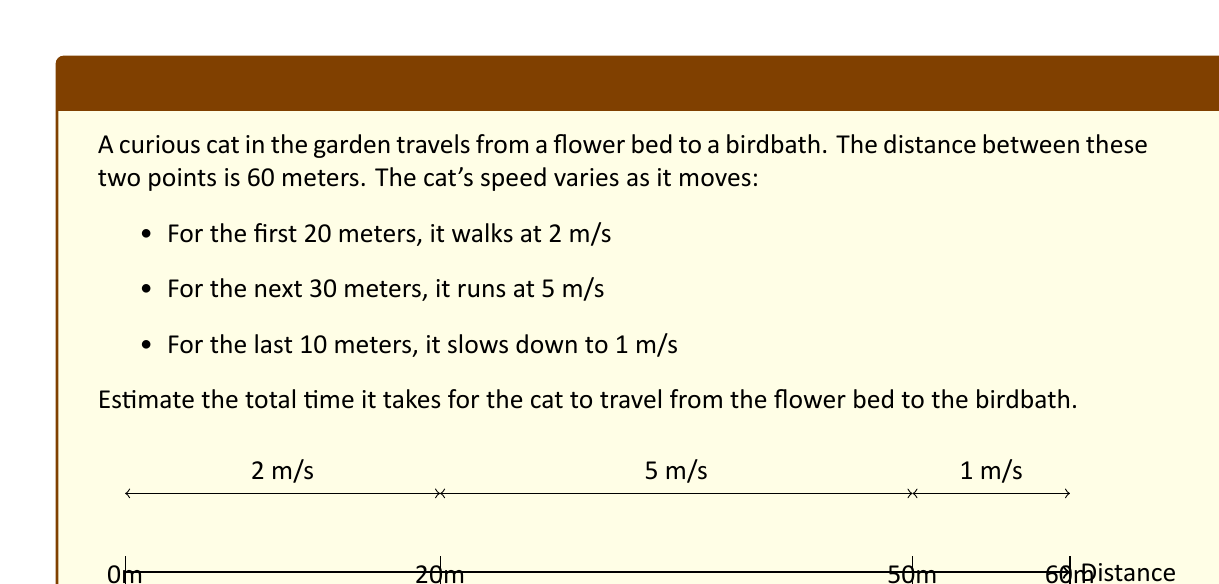Give your solution to this math problem. Let's break this problem down into steps:

1) We need to calculate the time for each segment of the journey and then sum them up.

2) For the first segment:
   Distance = 20 m, Speed = 2 m/s
   Time = Distance / Speed
   $t_1 = \frac{20}{2} = 10$ seconds

3) For the second segment:
   Distance = 30 m, Speed = 5 m/s
   $t_2 = \frac{30}{5} = 6$ seconds

4) For the third segment:
   Distance = 10 m, Speed = 1 m/s
   $t_3 = \frac{10}{1} = 10$ seconds

5) Total time is the sum of these three times:
   $t_{total} = t_1 + t_2 + t_3 = 10 + 6 + 10 = 26$ seconds

Therefore, it takes the cat 26 seconds to travel from the flower bed to the birdbath.
Answer: 26 seconds 